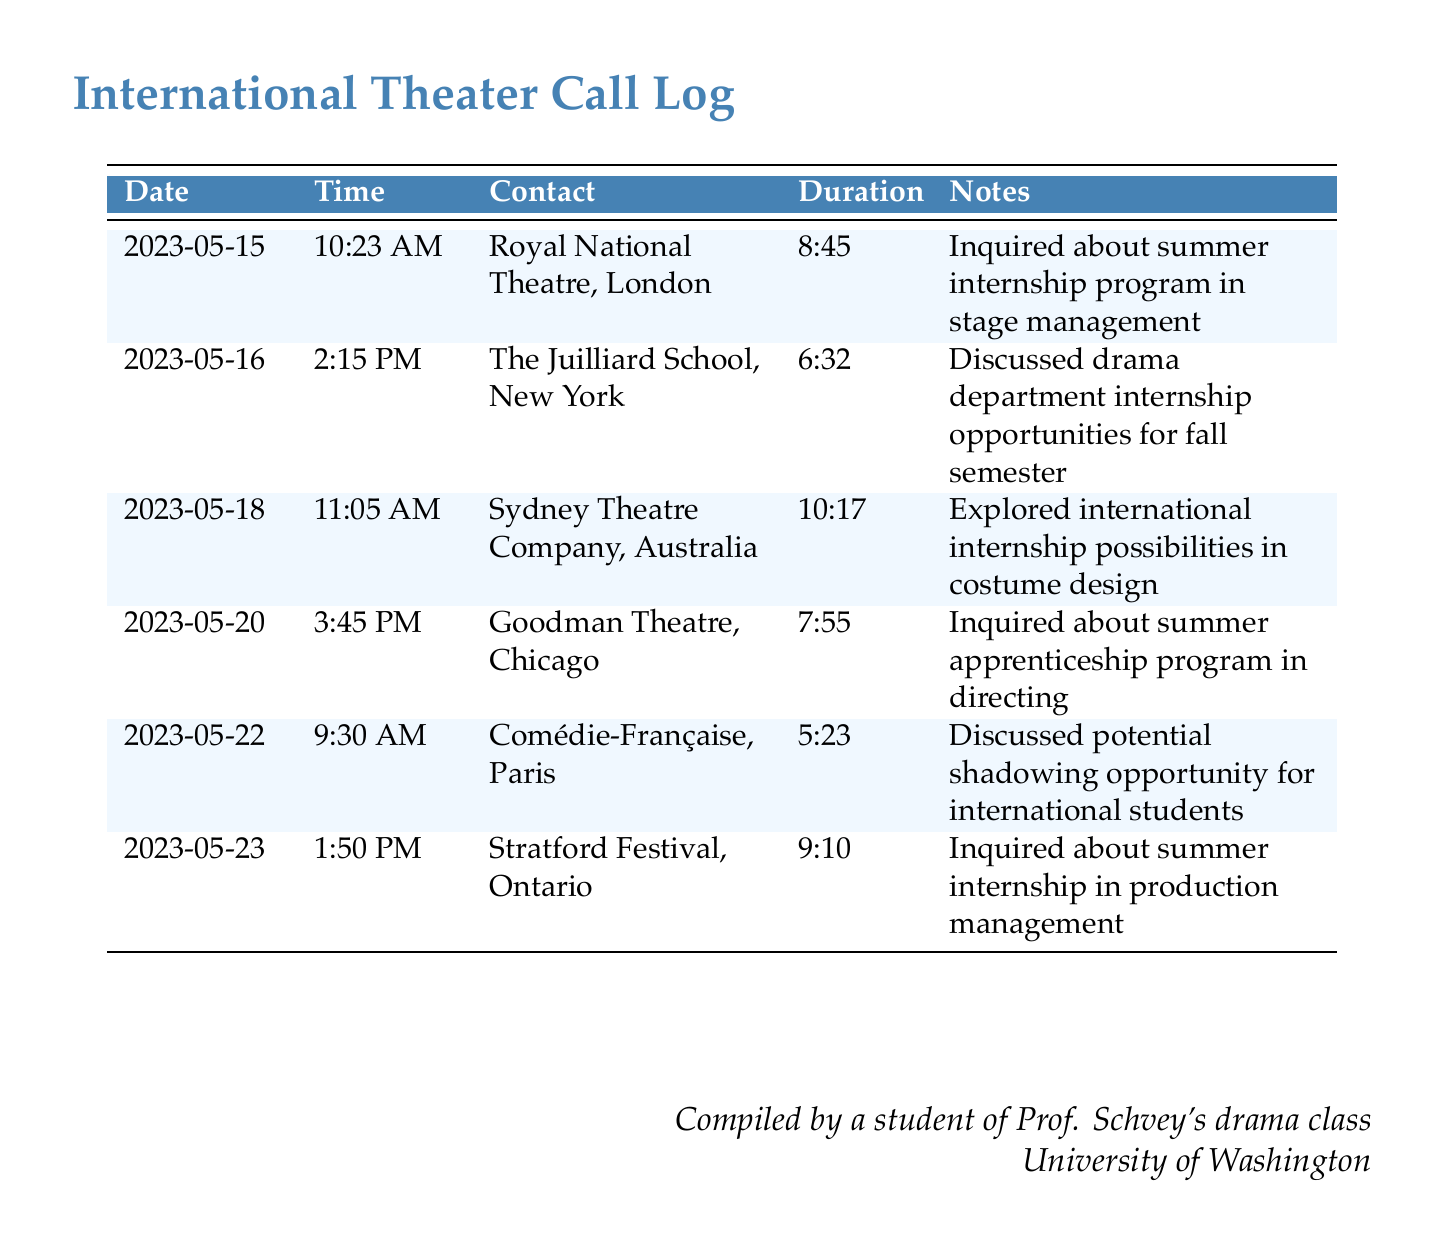What is the first contact listed in the log? The first contact listed is from the Royal National Theatre in London on May 15, 2023.
Answer: Royal National Theatre, London How long was the call made to The Juilliard School? The call duration to The Juilliard School is specified in the document as 6 minutes and 32 seconds.
Answer: 6:32 What was the primary topic of discussion during the call with Sydney Theatre Company? The document states that the discussion was about international internship possibilities in costume design.
Answer: Costume design How many calls were made in total according to the log? The document lists a total of six calls made to different theater companies and drama schools.
Answer: 6 Which theater company is located in Paris? The document specifies Comédie-Française as the theater company located in Paris.
Answer: Comédie-Française What date was the call made to Goodman Theatre? The call to Goodman Theatre is recorded on May 20, 2023.
Answer: 2023-05-20 Which internship opportunity was discussed during the call with Stratford Festival? The call with Stratford Festival was regarding a summer internship in production management.
Answer: Production management What was the last company contacted according to the log? The last company mentioned in the log is Stratford Festival based on the sequence of entries.
Answer: Stratford Festival, Ontario On what date was the shadowing opportunity discussed? The shadowing opportunity was discussed on May 22, 2023, with Comédie-Française.
Answer: 2023-05-22 What time was the longest call made? The longest call was made to the Sydney Theatre Company at 11:05 AM, lasting 10 minutes and 17 seconds.
Answer: 10:17 